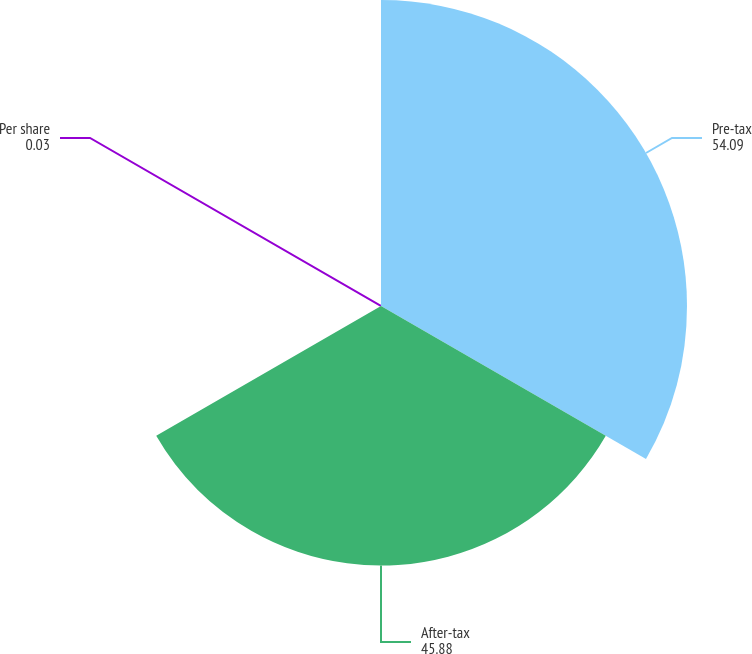<chart> <loc_0><loc_0><loc_500><loc_500><pie_chart><fcel>Pre-tax<fcel>After-tax<fcel>Per share<nl><fcel>54.09%<fcel>45.88%<fcel>0.03%<nl></chart> 